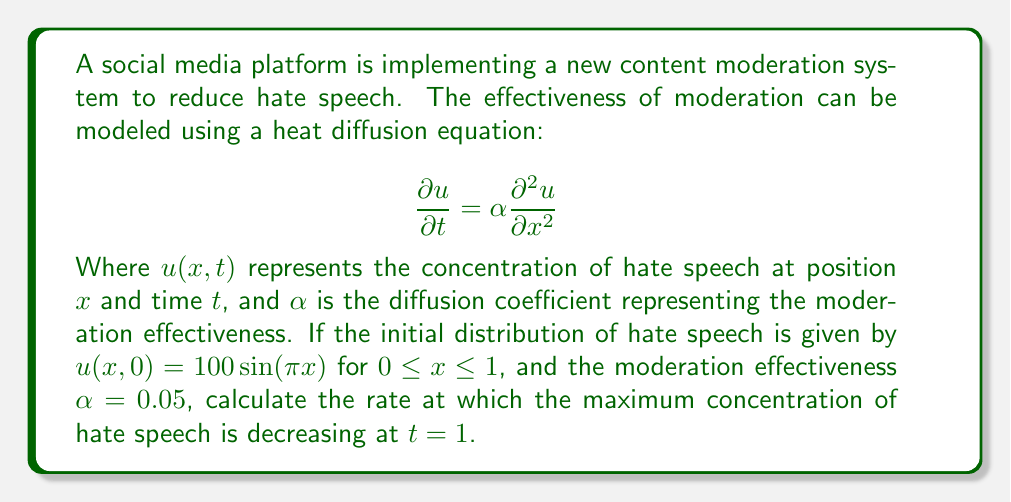Can you answer this question? To solve this problem, we'll follow these steps:

1) The general solution to the heat equation with the given initial condition is:

   $$u(x,t) = 100e^{-\alpha \pi^2 t} \sin(\pi x)$$

2) The maximum concentration occurs where $\sin(\pi x) = 1$, so the maximum concentration at any time $t$ is:

   $$u_{max}(t) = 100e^{-\alpha \pi^2 t}$$

3) To find the rate of change of the maximum concentration, we differentiate with respect to $t$:

   $$\frac{du_{max}}{dt} = -100\alpha \pi^2 e^{-\alpha \pi^2 t}$$

4) Now we substitute the given values: $\alpha = 0.05$ and $t = 1$:

   $$\frac{du_{max}}{dt}\bigg|_{t=1} = -100 \cdot 0.05 \cdot \pi^2 \cdot e^{-0.05 \pi^2 \cdot 1}$$

5) Calculating this:

   $$\frac{du_{max}}{dt}\bigg|_{t=1} \approx -14.74$$

This negative value indicates that the maximum concentration is decreasing at a rate of approximately 14.74 units per unit time at $t = 1$.
Answer: $-14.74$ units per unit time 